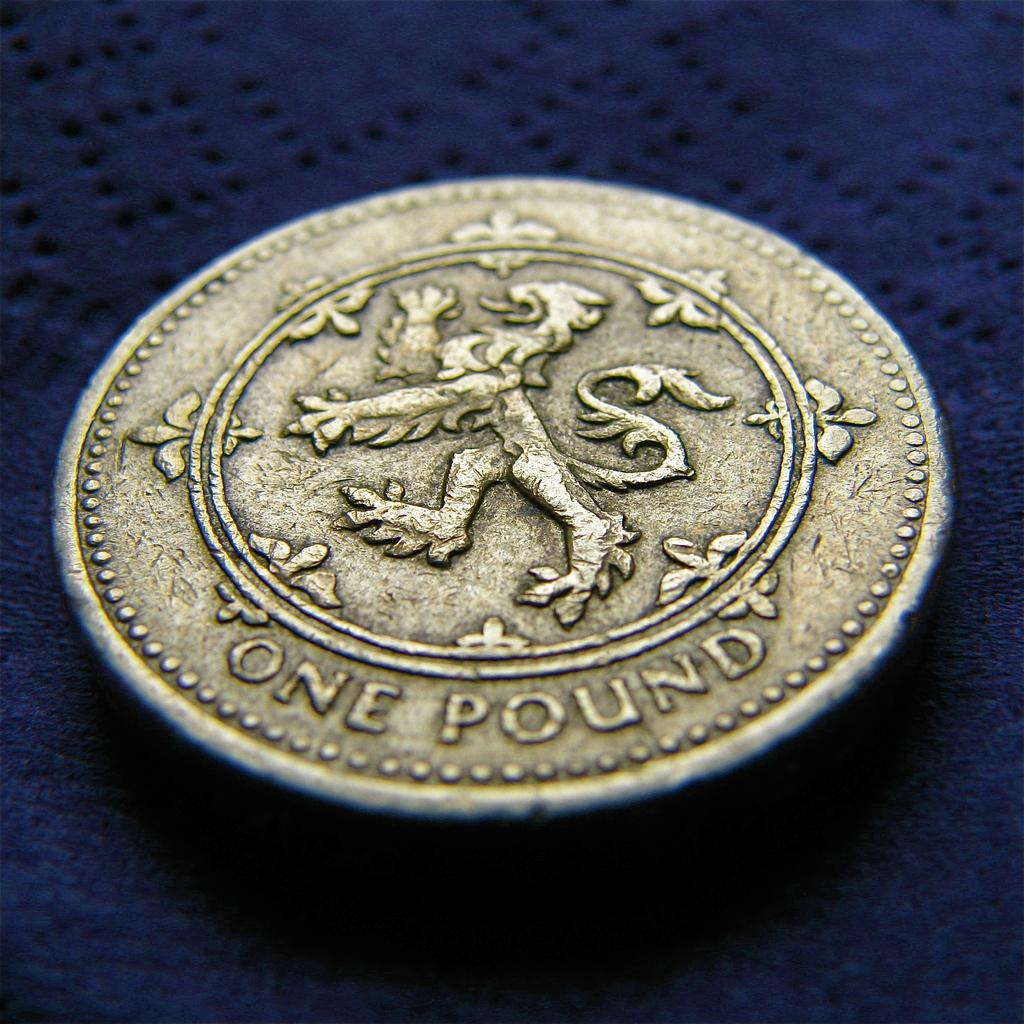<image>
Provide a brief description of the given image. a round gold coin with one pound written on it 